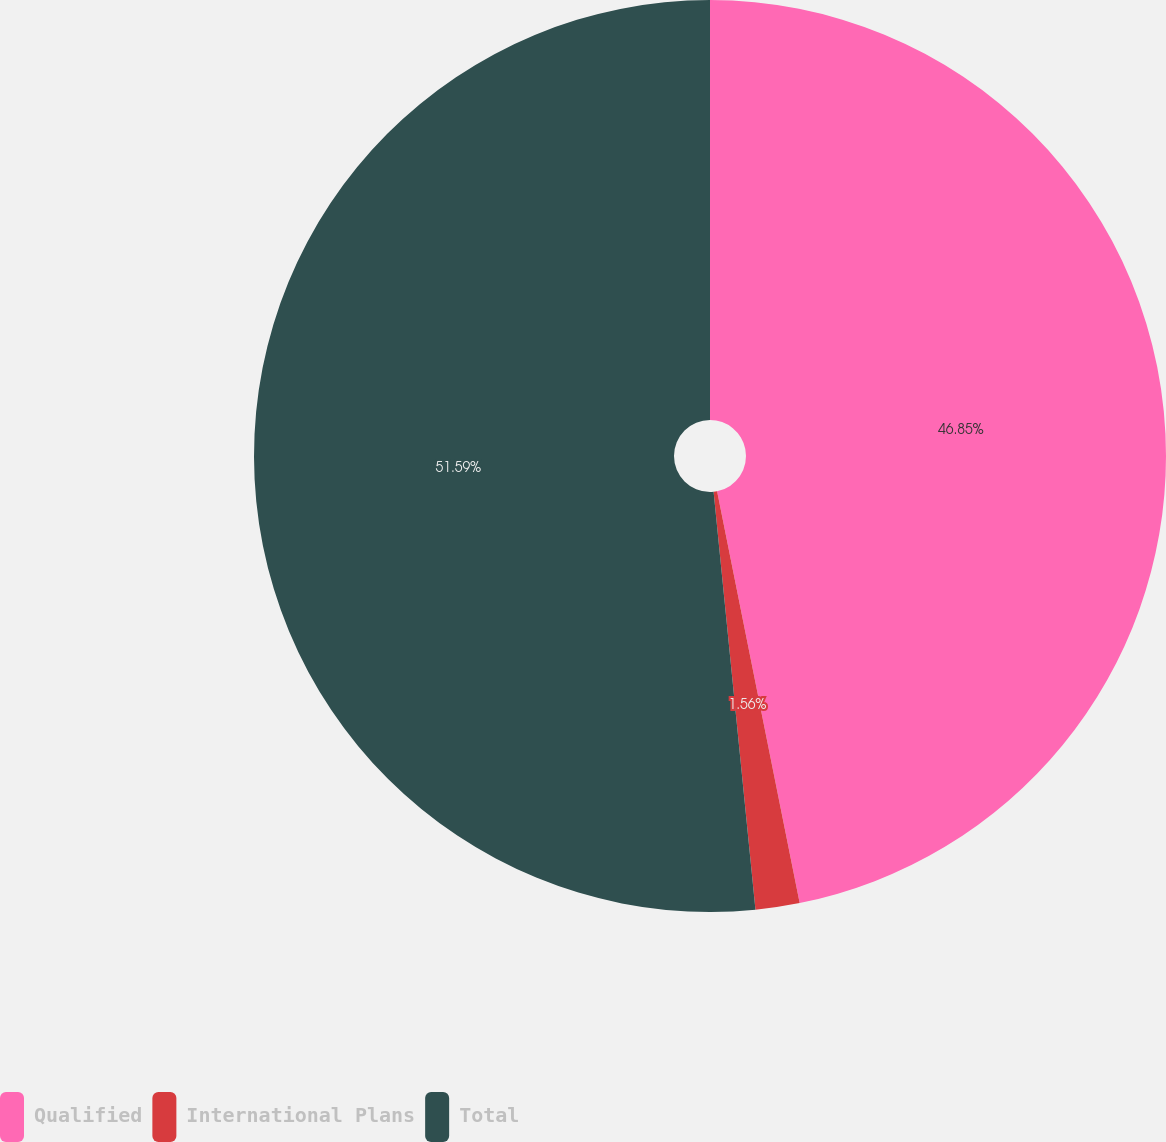Convert chart to OTSL. <chart><loc_0><loc_0><loc_500><loc_500><pie_chart><fcel>Qualified<fcel>International Plans<fcel>Total<nl><fcel>46.85%<fcel>1.56%<fcel>51.59%<nl></chart> 